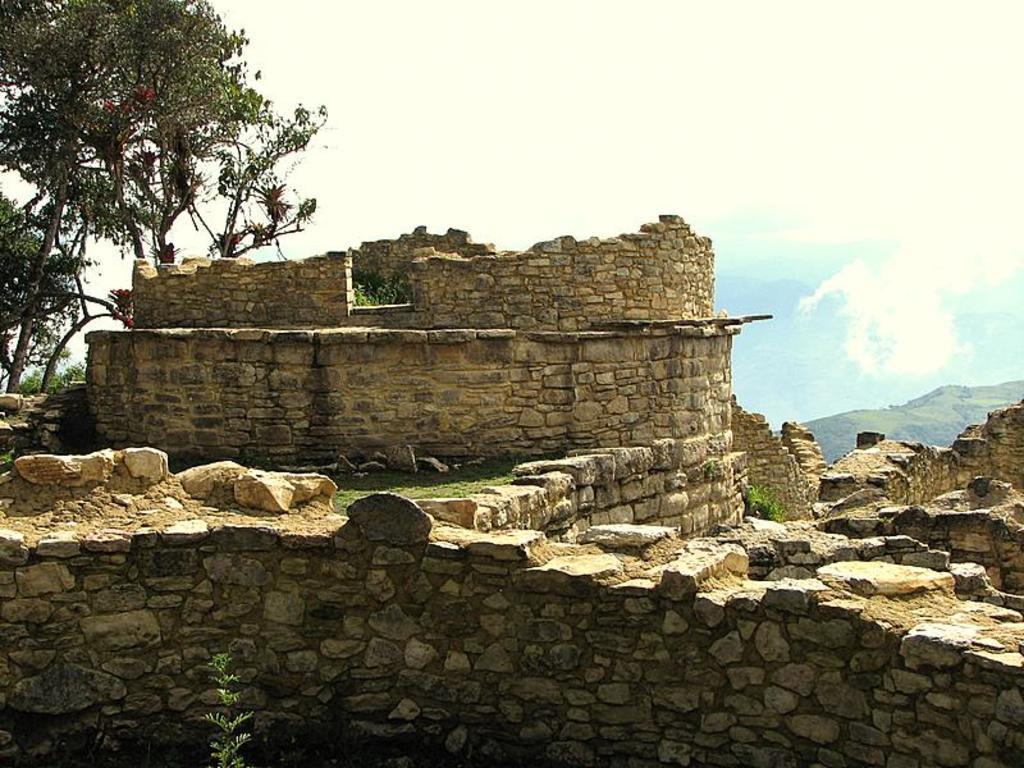What is the main structure in the center of the image? There is a fort in the center of the image. What type of natural elements can be seen in the image? There are rocks in the image. What can be seen in the background of the image? There are trees in the background of the image. What is visible at the top of the image? The sky is visible at the top of the image. What type of creature can be seen flying through the rainstorm in the image? There is no creature or rainstorm present in the image; it features a fort, rocks, trees, and the sky. 